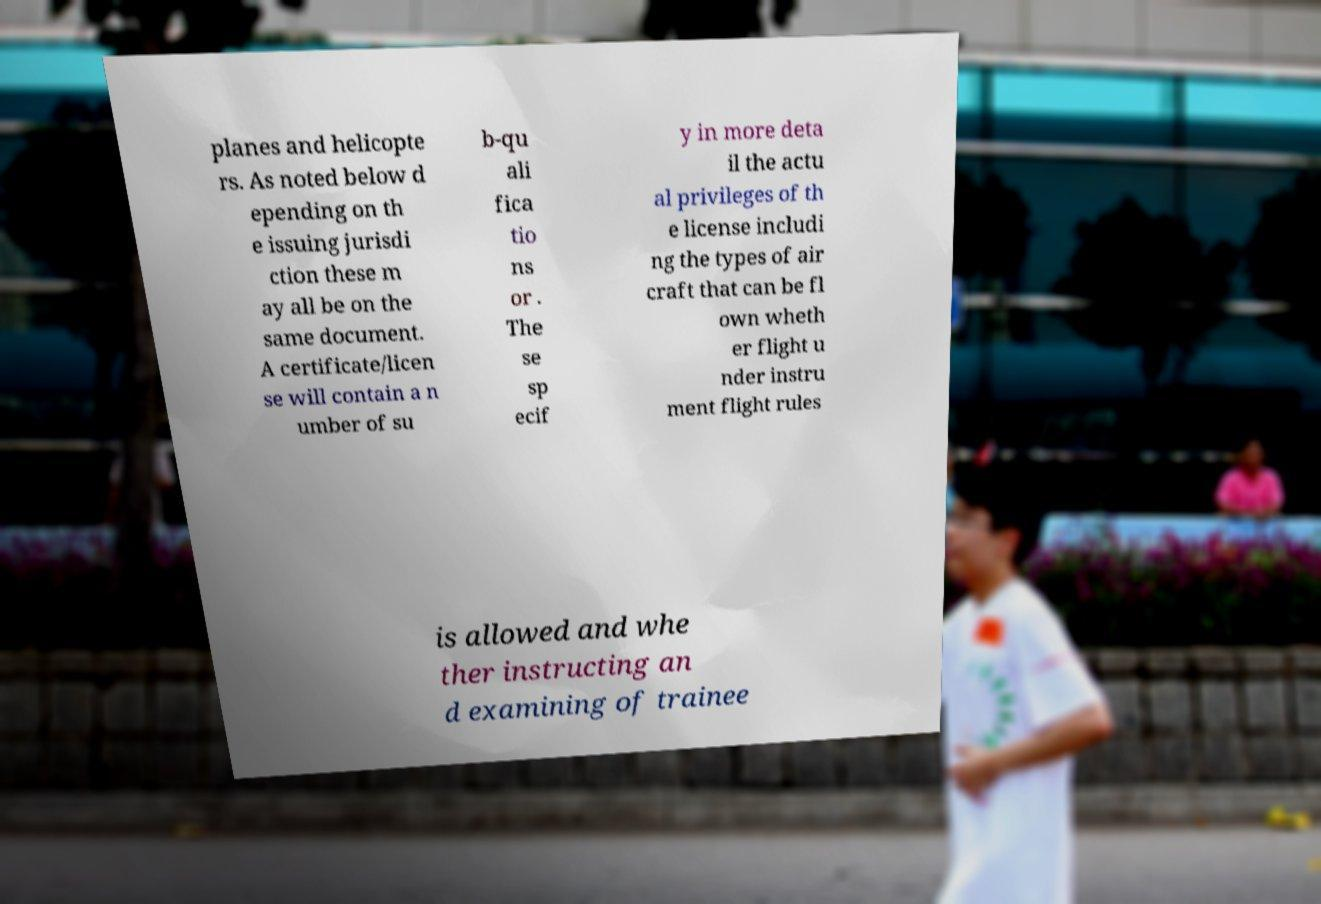Could you extract and type out the text from this image? planes and helicopte rs. As noted below d epending on th e issuing jurisdi ction these m ay all be on the same document. A certificate/licen se will contain a n umber of su b-qu ali fica tio ns or . The se sp ecif y in more deta il the actu al privileges of th e license includi ng the types of air craft that can be fl own wheth er flight u nder instru ment flight rules is allowed and whe ther instructing an d examining of trainee 